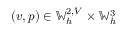<formula> <loc_0><loc_0><loc_500><loc_500>( v , p ) \in \mathbb { W } _ { h } ^ { 2 , V } \times \mathbb { W } _ { h } ^ { 3 }</formula> 